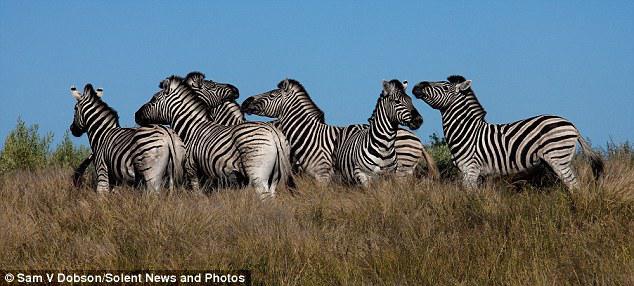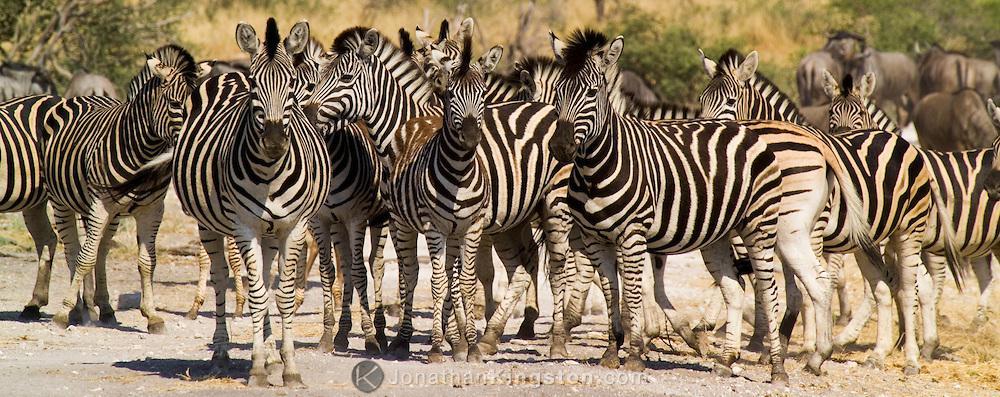The first image is the image on the left, the second image is the image on the right. For the images displayed, is the sentence "There are zebras drinking water." factually correct? Answer yes or no. No. The first image is the image on the left, the second image is the image on the right. Assess this claim about the two images: "An image shows a row of zebras with the adult zebras bending their necks to the water as they stand in water.". Correct or not? Answer yes or no. No. 